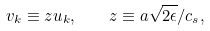<formula> <loc_0><loc_0><loc_500><loc_500>v _ { k } \equiv z u _ { k } , \quad z \equiv a \sqrt { 2 \epsilon } / c _ { s } ,</formula> 